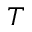Convert formula to latex. <formula><loc_0><loc_0><loc_500><loc_500>T</formula> 